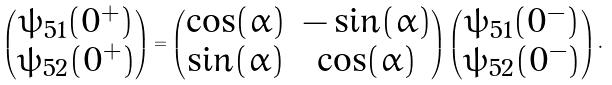Convert formula to latex. <formula><loc_0><loc_0><loc_500><loc_500>\left ( \begin{matrix} \psi _ { 5 1 } ( 0 ^ { + } ) \\ \psi _ { 5 2 } ( 0 ^ { + } ) \end{matrix} \right ) = \left ( \begin{matrix} \cos ( \alpha ) & - \sin ( \alpha ) \\ \sin ( \alpha ) & \cos ( \alpha ) \end{matrix} \right ) \left ( \begin{matrix} \psi _ { 5 1 } ( 0 ^ { - } ) \\ \psi _ { 5 2 } ( 0 ^ { - } ) \end{matrix} \right ) .</formula> 